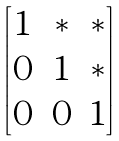<formula> <loc_0><loc_0><loc_500><loc_500>\begin{bmatrix} 1 & \ast & \ast \\ 0 & 1 & \ast \\ 0 & 0 & 1 \end{bmatrix}</formula> 